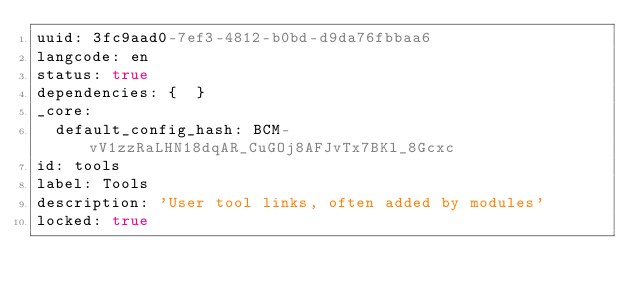Convert code to text. <code><loc_0><loc_0><loc_500><loc_500><_YAML_>uuid: 3fc9aad0-7ef3-4812-b0bd-d9da76fbbaa6
langcode: en
status: true
dependencies: {  }
_core:
  default_config_hash: BCM-vV1zzRaLHN18dqAR_CuGOj8AFJvTx7BKl_8Gcxc
id: tools
label: Tools
description: 'User tool links, often added by modules'
locked: true
</code> 